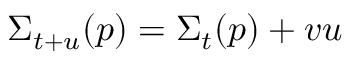Convert formula to latex. <formula><loc_0><loc_0><loc_500><loc_500>\Sigma _ { t + u } ( p ) = \Sigma _ { t } ( p ) + v u</formula> 